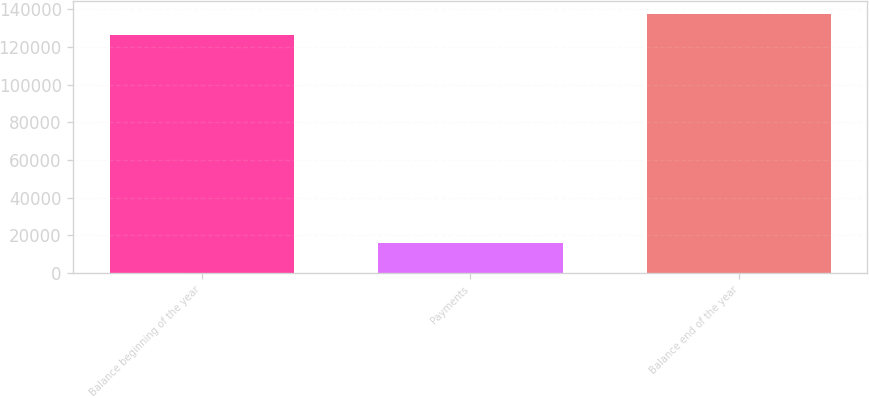Convert chart. <chart><loc_0><loc_0><loc_500><loc_500><bar_chart><fcel>Balance beginning of the year<fcel>Payments<fcel>Balance end of the year<nl><fcel>126260<fcel>16242<fcel>137638<nl></chart> 